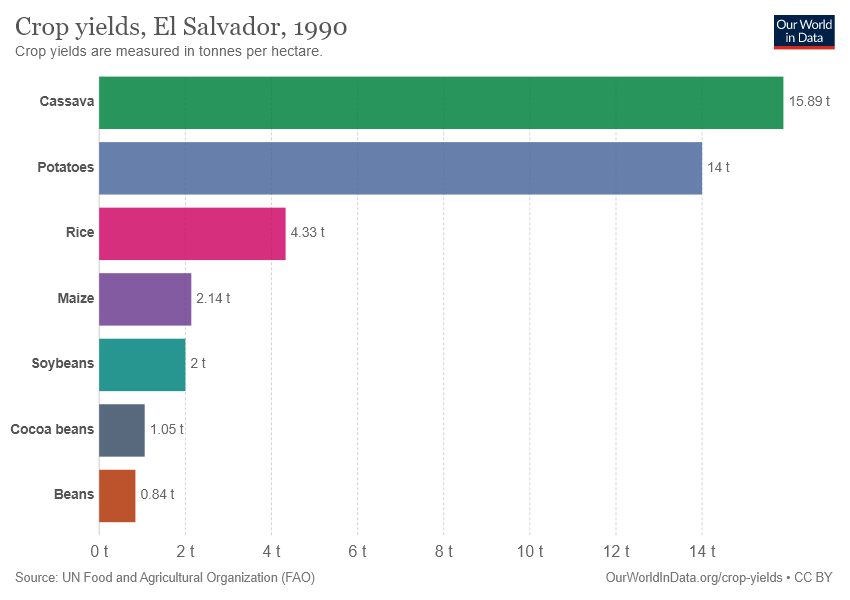Give some essential details in this illustration. The sum of the smallest two bars is less than the third largest bar. The value of cassava is 15.89. 